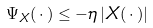<formula> <loc_0><loc_0><loc_500><loc_500>\Psi _ { X } ( \, \cdot \, ) \leq - \eta \, | X ( \, \cdot \, ) |</formula> 